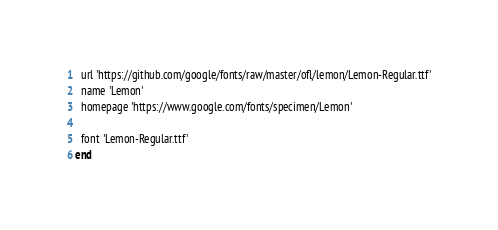Convert code to text. <code><loc_0><loc_0><loc_500><loc_500><_Ruby_>  url 'https://github.com/google/fonts/raw/master/ofl/lemon/Lemon-Regular.ttf'
  name 'Lemon'
  homepage 'https://www.google.com/fonts/specimen/Lemon'

  font 'Lemon-Regular.ttf'
end
</code> 